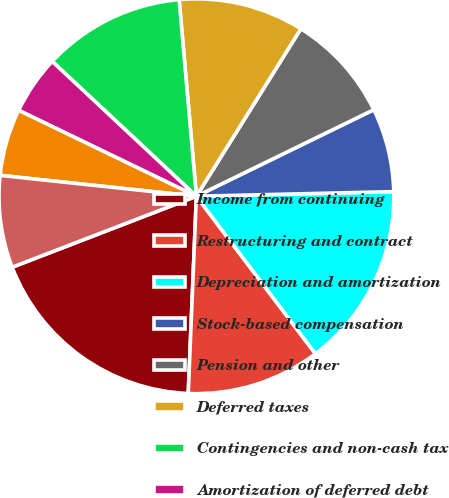Convert chart. <chart><loc_0><loc_0><loc_500><loc_500><pie_chart><fcel>Income from continuing<fcel>Restructuring and contract<fcel>Depreciation and amortization<fcel>Stock-based compensation<fcel>Pension and other<fcel>Deferred taxes<fcel>Contingencies and non-cash tax<fcel>Amortization of deferred debt<fcel>Asset Impairments<fcel>Accounts receivable net<nl><fcel>18.49%<fcel>10.96%<fcel>15.07%<fcel>6.85%<fcel>8.9%<fcel>10.27%<fcel>11.64%<fcel>4.8%<fcel>5.48%<fcel>7.54%<nl></chart> 